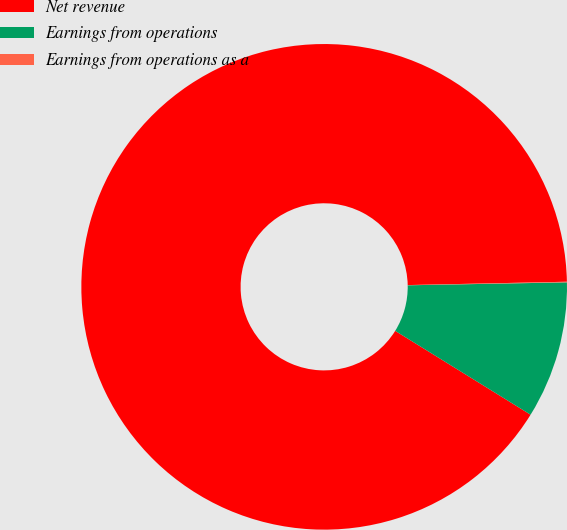<chart> <loc_0><loc_0><loc_500><loc_500><pie_chart><fcel>Net revenue<fcel>Earnings from operations<fcel>Earnings from operations as a<nl><fcel>90.83%<fcel>9.12%<fcel>0.04%<nl></chart> 